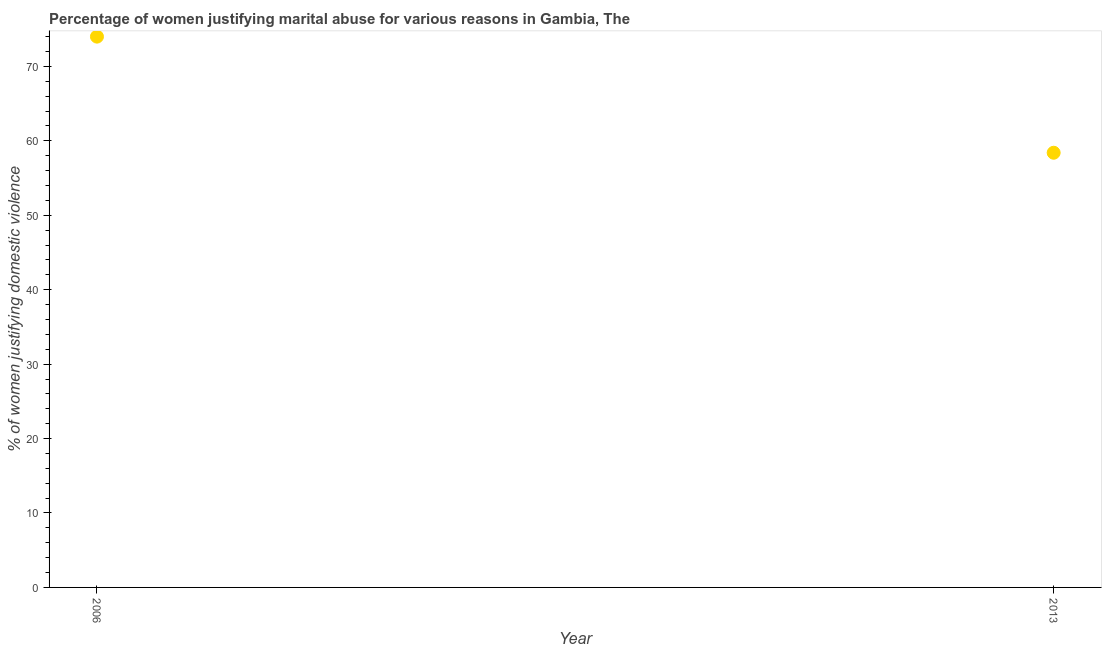Across all years, what is the maximum percentage of women justifying marital abuse?
Make the answer very short. 74. Across all years, what is the minimum percentage of women justifying marital abuse?
Your answer should be very brief. 58.4. In which year was the percentage of women justifying marital abuse minimum?
Provide a short and direct response. 2013. What is the sum of the percentage of women justifying marital abuse?
Ensure brevity in your answer.  132.4. What is the difference between the percentage of women justifying marital abuse in 2006 and 2013?
Offer a terse response. 15.6. What is the average percentage of women justifying marital abuse per year?
Keep it short and to the point. 66.2. What is the median percentage of women justifying marital abuse?
Your answer should be very brief. 66.2. In how many years, is the percentage of women justifying marital abuse greater than 14 %?
Provide a short and direct response. 2. Do a majority of the years between 2013 and 2006 (inclusive) have percentage of women justifying marital abuse greater than 52 %?
Offer a terse response. No. What is the ratio of the percentage of women justifying marital abuse in 2006 to that in 2013?
Your response must be concise. 1.27. How many dotlines are there?
Offer a very short reply. 1. How many years are there in the graph?
Offer a terse response. 2. What is the title of the graph?
Give a very brief answer. Percentage of women justifying marital abuse for various reasons in Gambia, The. What is the label or title of the Y-axis?
Keep it short and to the point. % of women justifying domestic violence. What is the % of women justifying domestic violence in 2006?
Offer a terse response. 74. What is the % of women justifying domestic violence in 2013?
Provide a succinct answer. 58.4. What is the difference between the % of women justifying domestic violence in 2006 and 2013?
Keep it short and to the point. 15.6. What is the ratio of the % of women justifying domestic violence in 2006 to that in 2013?
Ensure brevity in your answer.  1.27. 